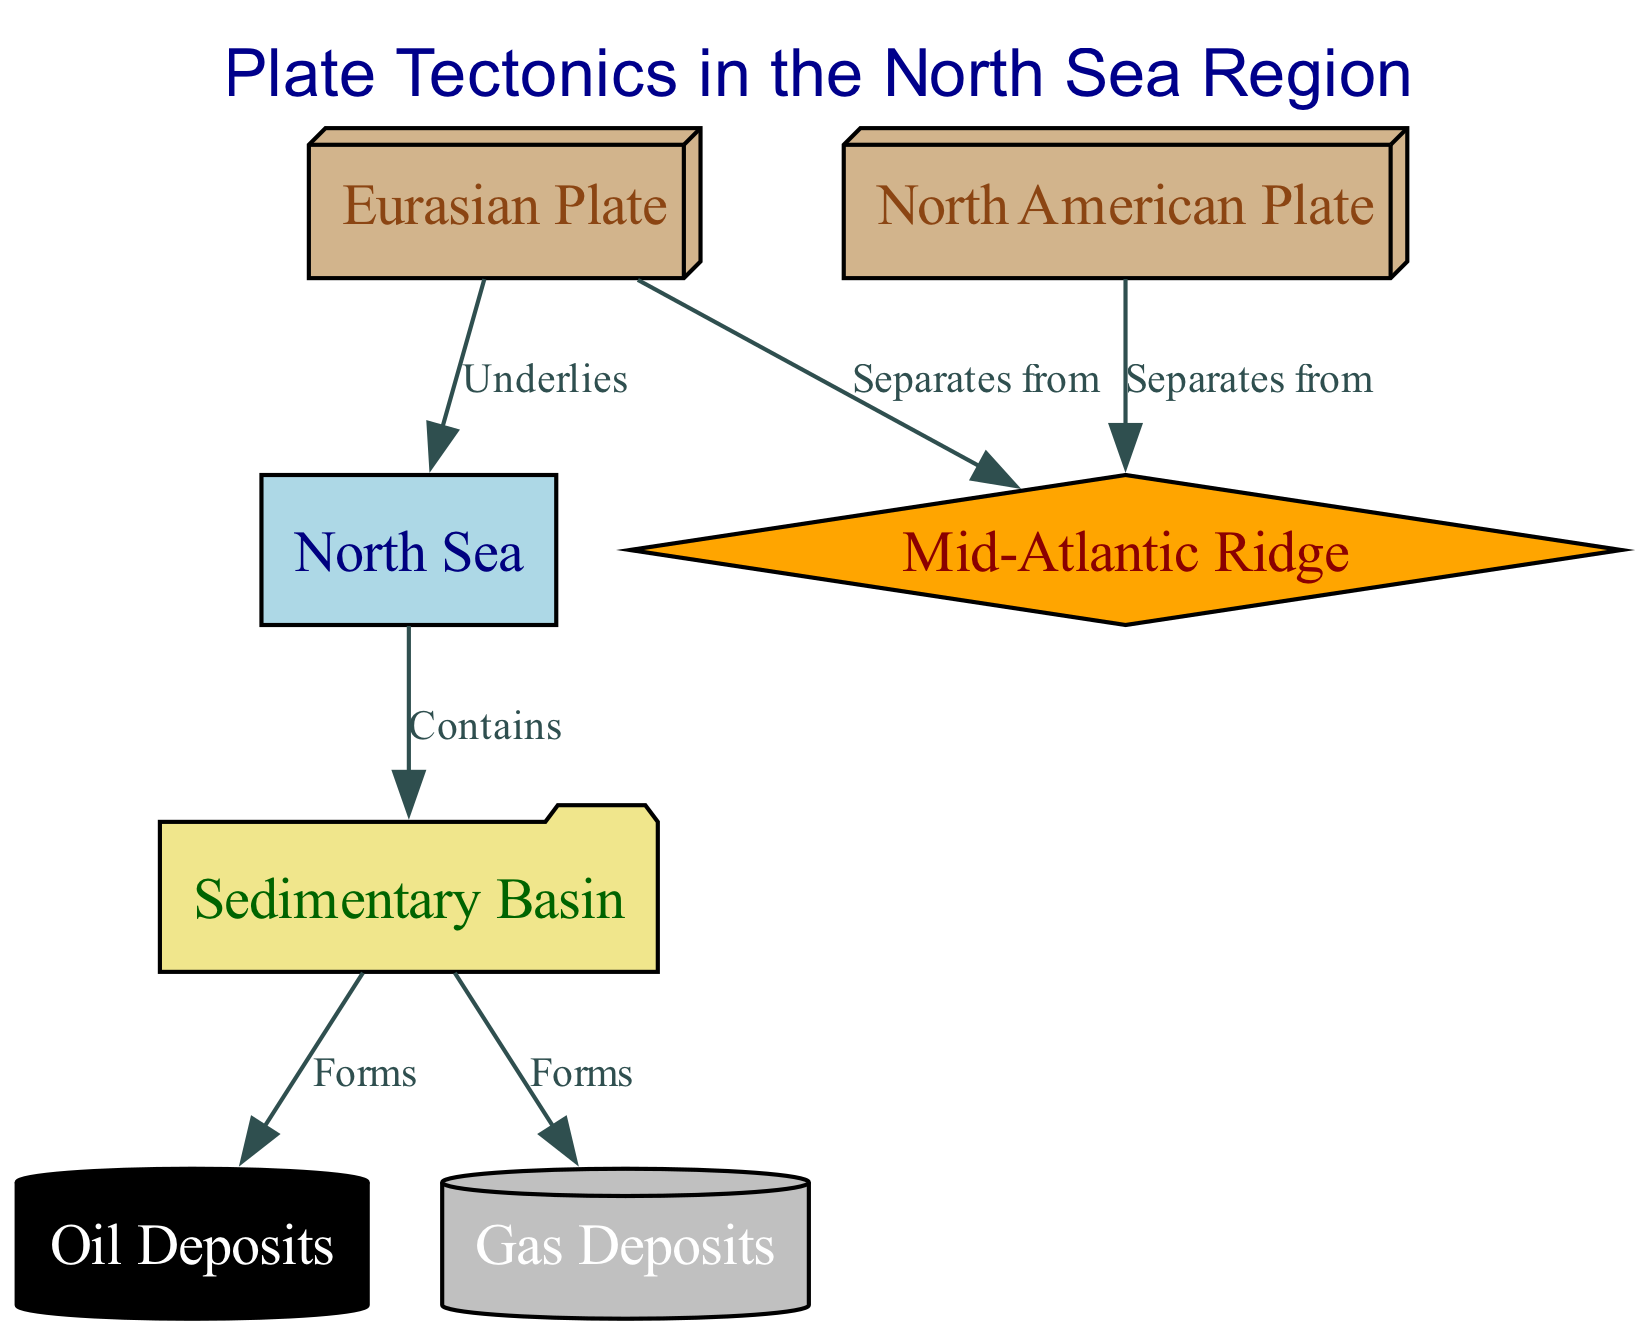What is the total number of nodes in the diagram? The diagram lists the nodes: North Sea, Eurasian Plate, North American Plate, Mid-Atlantic Ridge, Sedimentary Basin, Oil Deposits, and Gas Deposits. There are 7 nodes altogether.
Answer: 7 What two plates are involved in separating at the Mid-Atlantic Ridge? The Mid-Atlantic Ridge connects the North American Plate and the Eurasian Plate. Therefore, the two plates involved in separating at this ridge are the North American Plate and the Eurasian Plate.
Answer: North American Plate and Eurasian Plate What does the North Sea contain? According to the diagram, the North Sea "Contains" a Sedimentary Basin. This indicates the primary component within the North Sea as related to geological formations.
Answer: Sedimentary Basin What type of geological deposits form from the Sedimentary Basin? The diagram indicates that the Sedimentary Basin leads to the formation of both Oil Deposits and Gas Deposits, showcasing the types of fossil fuels that can be found in this region.
Answer: Oil Deposits and Gas Deposits Which plate underlies the North Sea? The diagram specifies that the Eurasian Plate "Underlies" the North Sea, establishing a foundational layer beneath this sea region.
Answer: Eurasian Plate What color represents Oil Deposits in the diagram? In this diagram, the Oil Deposits are represented by a black cylinder, indicating their visual differentiation from other geological features.
Answer: Black How are Oil Deposits and Gas Deposits related to the Sedimentary Basin? The diagram shows that both Oil Deposits and Gas Deposits are formed from the Sedimentary Basin, illustrating the direct relationship in which these resources emerge from the basin's geological processes.
Answer: Both form from Sedimentary Basin What role does the Mid-Atlantic Ridge play in the context of the North Sea? The Mid-Atlantic Ridge serves as a separating line between the Eurasian Plate and North American Plate, which helps contextualize the tectonic activity affecting the North Sea region.
Answer: Separates Eurasian and North American Plates 